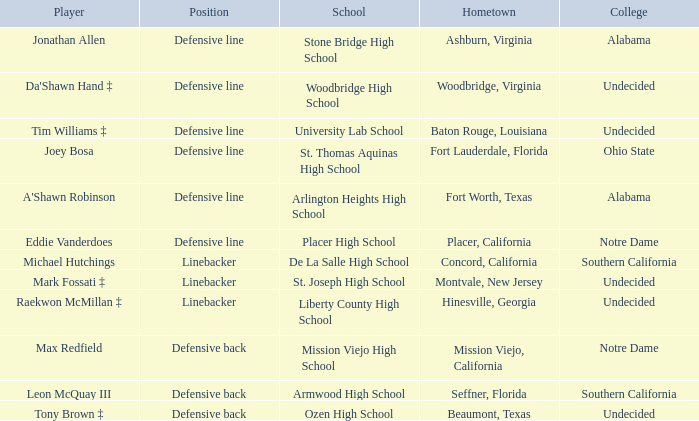What is the position of the player from Fort Lauderdale, Florida? Defensive line. 